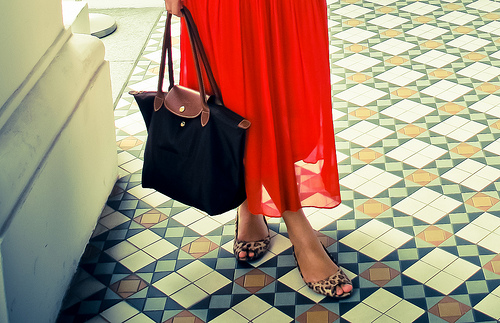<image>
Is there a women on the bag? No. The women is not positioned on the bag. They may be near each other, but the women is not supported by or resting on top of the bag. Is the bag next to the dress? Yes. The bag is positioned adjacent to the dress, located nearby in the same general area. Where is the red dress in relation to the black bag? Is it in the black bag? No. The red dress is not contained within the black bag. These objects have a different spatial relationship. 